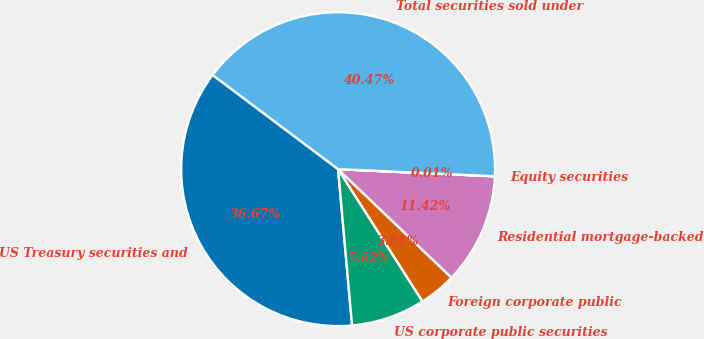Convert chart. <chart><loc_0><loc_0><loc_500><loc_500><pie_chart><fcel>US Treasury securities and<fcel>US corporate public securities<fcel>Foreign corporate public<fcel>Residential mortgage-backed<fcel>Equity securities<fcel>Total securities sold under<nl><fcel>36.67%<fcel>7.62%<fcel>3.81%<fcel>11.42%<fcel>0.01%<fcel>40.47%<nl></chart> 